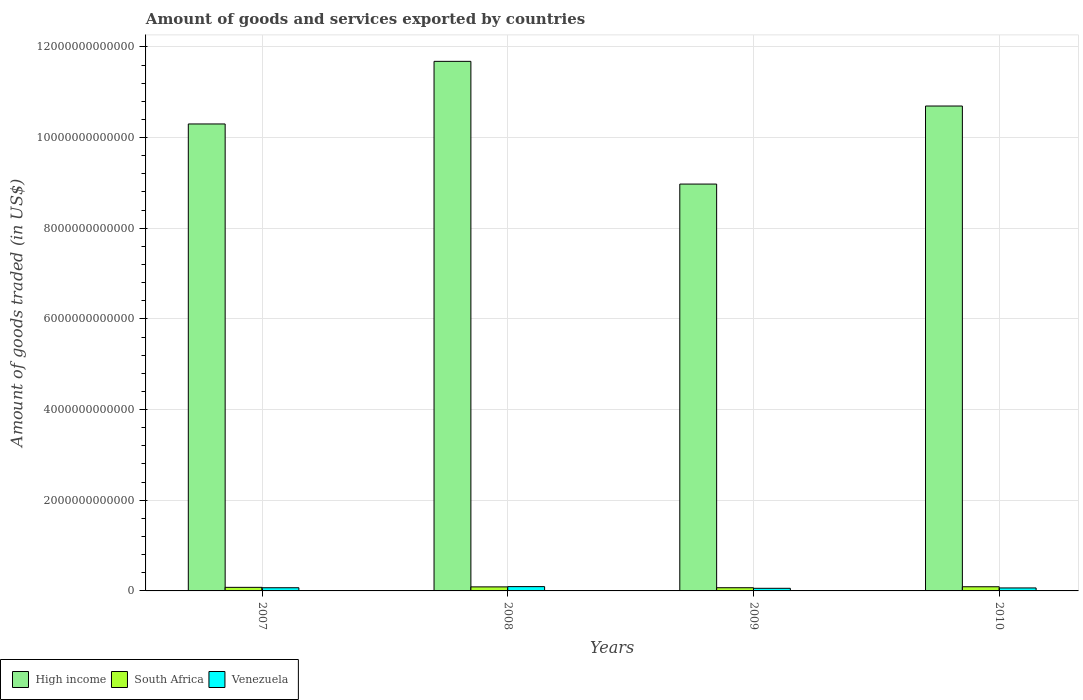How many different coloured bars are there?
Make the answer very short. 3. How many groups of bars are there?
Give a very brief answer. 4. Are the number of bars per tick equal to the number of legend labels?
Your response must be concise. Yes. What is the label of the 1st group of bars from the left?
Your answer should be very brief. 2007. In how many cases, is the number of bars for a given year not equal to the number of legend labels?
Ensure brevity in your answer.  0. What is the total amount of goods and services exported in Venezuela in 2008?
Make the answer very short. 9.50e+1. Across all years, what is the maximum total amount of goods and services exported in High income?
Ensure brevity in your answer.  1.17e+13. Across all years, what is the minimum total amount of goods and services exported in High income?
Keep it short and to the point. 8.97e+12. In which year was the total amount of goods and services exported in South Africa maximum?
Offer a terse response. 2010. What is the total total amount of goods and services exported in Venezuela in the graph?
Provide a short and direct response. 2.88e+11. What is the difference between the total amount of goods and services exported in High income in 2008 and that in 2010?
Offer a very short reply. 9.85e+11. What is the difference between the total amount of goods and services exported in High income in 2008 and the total amount of goods and services exported in Venezuela in 2007?
Ensure brevity in your answer.  1.16e+13. What is the average total amount of goods and services exported in Venezuela per year?
Provide a succinct answer. 7.21e+1. In the year 2008, what is the difference between the total amount of goods and services exported in Venezuela and total amount of goods and services exported in High income?
Ensure brevity in your answer.  -1.16e+13. What is the ratio of the total amount of goods and services exported in South Africa in 2007 to that in 2009?
Provide a short and direct response. 1.12. Is the total amount of goods and services exported in South Africa in 2007 less than that in 2010?
Keep it short and to the point. Yes. Is the difference between the total amount of goods and services exported in Venezuela in 2007 and 2008 greater than the difference between the total amount of goods and services exported in High income in 2007 and 2008?
Give a very brief answer. Yes. What is the difference between the highest and the second highest total amount of goods and services exported in South Africa?
Your answer should be very brief. 2.64e+09. What is the difference between the highest and the lowest total amount of goods and services exported in High income?
Your response must be concise. 2.71e+12. In how many years, is the total amount of goods and services exported in High income greater than the average total amount of goods and services exported in High income taken over all years?
Make the answer very short. 2. Is the sum of the total amount of goods and services exported in Venezuela in 2009 and 2010 greater than the maximum total amount of goods and services exported in High income across all years?
Your answer should be compact. No. What does the 3rd bar from the left in 2009 represents?
Offer a terse response. Venezuela. What does the 1st bar from the right in 2010 represents?
Ensure brevity in your answer.  Venezuela. What is the difference between two consecutive major ticks on the Y-axis?
Offer a terse response. 2.00e+12. Does the graph contain any zero values?
Offer a terse response. No. How are the legend labels stacked?
Offer a very short reply. Horizontal. What is the title of the graph?
Give a very brief answer. Amount of goods and services exported by countries. What is the label or title of the X-axis?
Make the answer very short. Years. What is the label or title of the Y-axis?
Provide a short and direct response. Amount of goods traded (in US$). What is the Amount of goods traded (in US$) in High income in 2007?
Your answer should be compact. 1.03e+13. What is the Amount of goods traded (in US$) of South Africa in 2007?
Your answer should be very brief. 7.87e+1. What is the Amount of goods traded (in US$) in Venezuela in 2007?
Your answer should be compact. 7.00e+1. What is the Amount of goods traded (in US$) of High income in 2008?
Offer a terse response. 1.17e+13. What is the Amount of goods traded (in US$) of South Africa in 2008?
Your response must be concise. 8.90e+1. What is the Amount of goods traded (in US$) of Venezuela in 2008?
Provide a short and direct response. 9.50e+1. What is the Amount of goods traded (in US$) of High income in 2009?
Keep it short and to the point. 8.97e+12. What is the Amount of goods traded (in US$) in South Africa in 2009?
Provide a succinct answer. 7.06e+1. What is the Amount of goods traded (in US$) of Venezuela in 2009?
Provide a succinct answer. 5.76e+1. What is the Amount of goods traded (in US$) of High income in 2010?
Make the answer very short. 1.07e+13. What is the Amount of goods traded (in US$) in South Africa in 2010?
Your answer should be very brief. 9.17e+1. What is the Amount of goods traded (in US$) in Venezuela in 2010?
Offer a terse response. 6.57e+1. Across all years, what is the maximum Amount of goods traded (in US$) of High income?
Your response must be concise. 1.17e+13. Across all years, what is the maximum Amount of goods traded (in US$) in South Africa?
Give a very brief answer. 9.17e+1. Across all years, what is the maximum Amount of goods traded (in US$) in Venezuela?
Offer a terse response. 9.50e+1. Across all years, what is the minimum Amount of goods traded (in US$) of High income?
Ensure brevity in your answer.  8.97e+12. Across all years, what is the minimum Amount of goods traded (in US$) of South Africa?
Keep it short and to the point. 7.06e+1. Across all years, what is the minimum Amount of goods traded (in US$) of Venezuela?
Your answer should be very brief. 5.76e+1. What is the total Amount of goods traded (in US$) of High income in the graph?
Your answer should be compact. 4.17e+13. What is the total Amount of goods traded (in US$) of South Africa in the graph?
Provide a succinct answer. 3.30e+11. What is the total Amount of goods traded (in US$) of Venezuela in the graph?
Offer a terse response. 2.88e+11. What is the difference between the Amount of goods traded (in US$) in High income in 2007 and that in 2008?
Provide a short and direct response. -1.38e+12. What is the difference between the Amount of goods traded (in US$) of South Africa in 2007 and that in 2008?
Your answer should be very brief. -1.03e+1. What is the difference between the Amount of goods traded (in US$) in Venezuela in 2007 and that in 2008?
Offer a very short reply. -2.50e+1. What is the difference between the Amount of goods traded (in US$) in High income in 2007 and that in 2009?
Offer a terse response. 1.33e+12. What is the difference between the Amount of goods traded (in US$) of South Africa in 2007 and that in 2009?
Offer a very short reply. 8.14e+09. What is the difference between the Amount of goods traded (in US$) in Venezuela in 2007 and that in 2009?
Your response must be concise. 1.24e+1. What is the difference between the Amount of goods traded (in US$) in High income in 2007 and that in 2010?
Offer a very short reply. -3.96e+11. What is the difference between the Amount of goods traded (in US$) in South Africa in 2007 and that in 2010?
Provide a succinct answer. -1.30e+1. What is the difference between the Amount of goods traded (in US$) of Venezuela in 2007 and that in 2010?
Your answer should be very brief. 4.24e+09. What is the difference between the Amount of goods traded (in US$) in High income in 2008 and that in 2009?
Your response must be concise. 2.71e+12. What is the difference between the Amount of goods traded (in US$) in South Africa in 2008 and that in 2009?
Make the answer very short. 1.85e+1. What is the difference between the Amount of goods traded (in US$) in Venezuela in 2008 and that in 2009?
Your answer should be compact. 3.74e+1. What is the difference between the Amount of goods traded (in US$) in High income in 2008 and that in 2010?
Your response must be concise. 9.85e+11. What is the difference between the Amount of goods traded (in US$) in South Africa in 2008 and that in 2010?
Keep it short and to the point. -2.64e+09. What is the difference between the Amount of goods traded (in US$) of Venezuela in 2008 and that in 2010?
Your answer should be compact. 2.93e+1. What is the difference between the Amount of goods traded (in US$) of High income in 2009 and that in 2010?
Give a very brief answer. -1.72e+12. What is the difference between the Amount of goods traded (in US$) of South Africa in 2009 and that in 2010?
Your answer should be compact. -2.11e+1. What is the difference between the Amount of goods traded (in US$) of Venezuela in 2009 and that in 2010?
Make the answer very short. -8.14e+09. What is the difference between the Amount of goods traded (in US$) of High income in 2007 and the Amount of goods traded (in US$) of South Africa in 2008?
Your answer should be compact. 1.02e+13. What is the difference between the Amount of goods traded (in US$) in High income in 2007 and the Amount of goods traded (in US$) in Venezuela in 2008?
Provide a succinct answer. 1.02e+13. What is the difference between the Amount of goods traded (in US$) of South Africa in 2007 and the Amount of goods traded (in US$) of Venezuela in 2008?
Your answer should be compact. -1.63e+1. What is the difference between the Amount of goods traded (in US$) in High income in 2007 and the Amount of goods traded (in US$) in South Africa in 2009?
Your answer should be very brief. 1.02e+13. What is the difference between the Amount of goods traded (in US$) of High income in 2007 and the Amount of goods traded (in US$) of Venezuela in 2009?
Your answer should be compact. 1.02e+13. What is the difference between the Amount of goods traded (in US$) of South Africa in 2007 and the Amount of goods traded (in US$) of Venezuela in 2009?
Offer a terse response. 2.11e+1. What is the difference between the Amount of goods traded (in US$) of High income in 2007 and the Amount of goods traded (in US$) of South Africa in 2010?
Make the answer very short. 1.02e+13. What is the difference between the Amount of goods traded (in US$) in High income in 2007 and the Amount of goods traded (in US$) in Venezuela in 2010?
Your answer should be very brief. 1.02e+13. What is the difference between the Amount of goods traded (in US$) in South Africa in 2007 and the Amount of goods traded (in US$) in Venezuela in 2010?
Your answer should be very brief. 1.30e+1. What is the difference between the Amount of goods traded (in US$) of High income in 2008 and the Amount of goods traded (in US$) of South Africa in 2009?
Offer a very short reply. 1.16e+13. What is the difference between the Amount of goods traded (in US$) of High income in 2008 and the Amount of goods traded (in US$) of Venezuela in 2009?
Provide a short and direct response. 1.16e+13. What is the difference between the Amount of goods traded (in US$) of South Africa in 2008 and the Amount of goods traded (in US$) of Venezuela in 2009?
Give a very brief answer. 3.14e+1. What is the difference between the Amount of goods traded (in US$) in High income in 2008 and the Amount of goods traded (in US$) in South Africa in 2010?
Offer a terse response. 1.16e+13. What is the difference between the Amount of goods traded (in US$) in High income in 2008 and the Amount of goods traded (in US$) in Venezuela in 2010?
Your response must be concise. 1.16e+13. What is the difference between the Amount of goods traded (in US$) in South Africa in 2008 and the Amount of goods traded (in US$) in Venezuela in 2010?
Ensure brevity in your answer.  2.33e+1. What is the difference between the Amount of goods traded (in US$) in High income in 2009 and the Amount of goods traded (in US$) in South Africa in 2010?
Your answer should be very brief. 8.88e+12. What is the difference between the Amount of goods traded (in US$) in High income in 2009 and the Amount of goods traded (in US$) in Venezuela in 2010?
Provide a short and direct response. 8.91e+12. What is the difference between the Amount of goods traded (in US$) in South Africa in 2009 and the Amount of goods traded (in US$) in Venezuela in 2010?
Your answer should be compact. 4.82e+09. What is the average Amount of goods traded (in US$) in High income per year?
Your answer should be very brief. 1.04e+13. What is the average Amount of goods traded (in US$) in South Africa per year?
Your response must be concise. 8.25e+1. What is the average Amount of goods traded (in US$) in Venezuela per year?
Your response must be concise. 7.21e+1. In the year 2007, what is the difference between the Amount of goods traded (in US$) of High income and Amount of goods traded (in US$) of South Africa?
Provide a short and direct response. 1.02e+13. In the year 2007, what is the difference between the Amount of goods traded (in US$) of High income and Amount of goods traded (in US$) of Venezuela?
Provide a short and direct response. 1.02e+13. In the year 2007, what is the difference between the Amount of goods traded (in US$) in South Africa and Amount of goods traded (in US$) in Venezuela?
Your answer should be very brief. 8.72e+09. In the year 2008, what is the difference between the Amount of goods traded (in US$) of High income and Amount of goods traded (in US$) of South Africa?
Your answer should be very brief. 1.16e+13. In the year 2008, what is the difference between the Amount of goods traded (in US$) in High income and Amount of goods traded (in US$) in Venezuela?
Ensure brevity in your answer.  1.16e+13. In the year 2008, what is the difference between the Amount of goods traded (in US$) in South Africa and Amount of goods traded (in US$) in Venezuela?
Your response must be concise. -5.99e+09. In the year 2009, what is the difference between the Amount of goods traded (in US$) of High income and Amount of goods traded (in US$) of South Africa?
Provide a short and direct response. 8.90e+12. In the year 2009, what is the difference between the Amount of goods traded (in US$) in High income and Amount of goods traded (in US$) in Venezuela?
Offer a terse response. 8.92e+12. In the year 2009, what is the difference between the Amount of goods traded (in US$) of South Africa and Amount of goods traded (in US$) of Venezuela?
Give a very brief answer. 1.30e+1. In the year 2010, what is the difference between the Amount of goods traded (in US$) of High income and Amount of goods traded (in US$) of South Africa?
Your answer should be very brief. 1.06e+13. In the year 2010, what is the difference between the Amount of goods traded (in US$) of High income and Amount of goods traded (in US$) of Venezuela?
Provide a short and direct response. 1.06e+13. In the year 2010, what is the difference between the Amount of goods traded (in US$) of South Africa and Amount of goods traded (in US$) of Venezuela?
Give a very brief answer. 2.59e+1. What is the ratio of the Amount of goods traded (in US$) in High income in 2007 to that in 2008?
Offer a terse response. 0.88. What is the ratio of the Amount of goods traded (in US$) of South Africa in 2007 to that in 2008?
Your response must be concise. 0.88. What is the ratio of the Amount of goods traded (in US$) of Venezuela in 2007 to that in 2008?
Provide a succinct answer. 0.74. What is the ratio of the Amount of goods traded (in US$) of High income in 2007 to that in 2009?
Make the answer very short. 1.15. What is the ratio of the Amount of goods traded (in US$) in South Africa in 2007 to that in 2009?
Your response must be concise. 1.12. What is the ratio of the Amount of goods traded (in US$) in Venezuela in 2007 to that in 2009?
Offer a very short reply. 1.21. What is the ratio of the Amount of goods traded (in US$) in South Africa in 2007 to that in 2010?
Offer a very short reply. 0.86. What is the ratio of the Amount of goods traded (in US$) of Venezuela in 2007 to that in 2010?
Keep it short and to the point. 1.06. What is the ratio of the Amount of goods traded (in US$) in High income in 2008 to that in 2009?
Provide a succinct answer. 1.3. What is the ratio of the Amount of goods traded (in US$) of South Africa in 2008 to that in 2009?
Offer a terse response. 1.26. What is the ratio of the Amount of goods traded (in US$) of Venezuela in 2008 to that in 2009?
Make the answer very short. 1.65. What is the ratio of the Amount of goods traded (in US$) of High income in 2008 to that in 2010?
Your answer should be very brief. 1.09. What is the ratio of the Amount of goods traded (in US$) of South Africa in 2008 to that in 2010?
Ensure brevity in your answer.  0.97. What is the ratio of the Amount of goods traded (in US$) of Venezuela in 2008 to that in 2010?
Your answer should be very brief. 1.45. What is the ratio of the Amount of goods traded (in US$) in High income in 2009 to that in 2010?
Your answer should be very brief. 0.84. What is the ratio of the Amount of goods traded (in US$) of South Africa in 2009 to that in 2010?
Keep it short and to the point. 0.77. What is the ratio of the Amount of goods traded (in US$) of Venezuela in 2009 to that in 2010?
Provide a short and direct response. 0.88. What is the difference between the highest and the second highest Amount of goods traded (in US$) of High income?
Your answer should be very brief. 9.85e+11. What is the difference between the highest and the second highest Amount of goods traded (in US$) in South Africa?
Your response must be concise. 2.64e+09. What is the difference between the highest and the second highest Amount of goods traded (in US$) of Venezuela?
Ensure brevity in your answer.  2.50e+1. What is the difference between the highest and the lowest Amount of goods traded (in US$) in High income?
Provide a succinct answer. 2.71e+12. What is the difference between the highest and the lowest Amount of goods traded (in US$) in South Africa?
Ensure brevity in your answer.  2.11e+1. What is the difference between the highest and the lowest Amount of goods traded (in US$) in Venezuela?
Your answer should be very brief. 3.74e+1. 